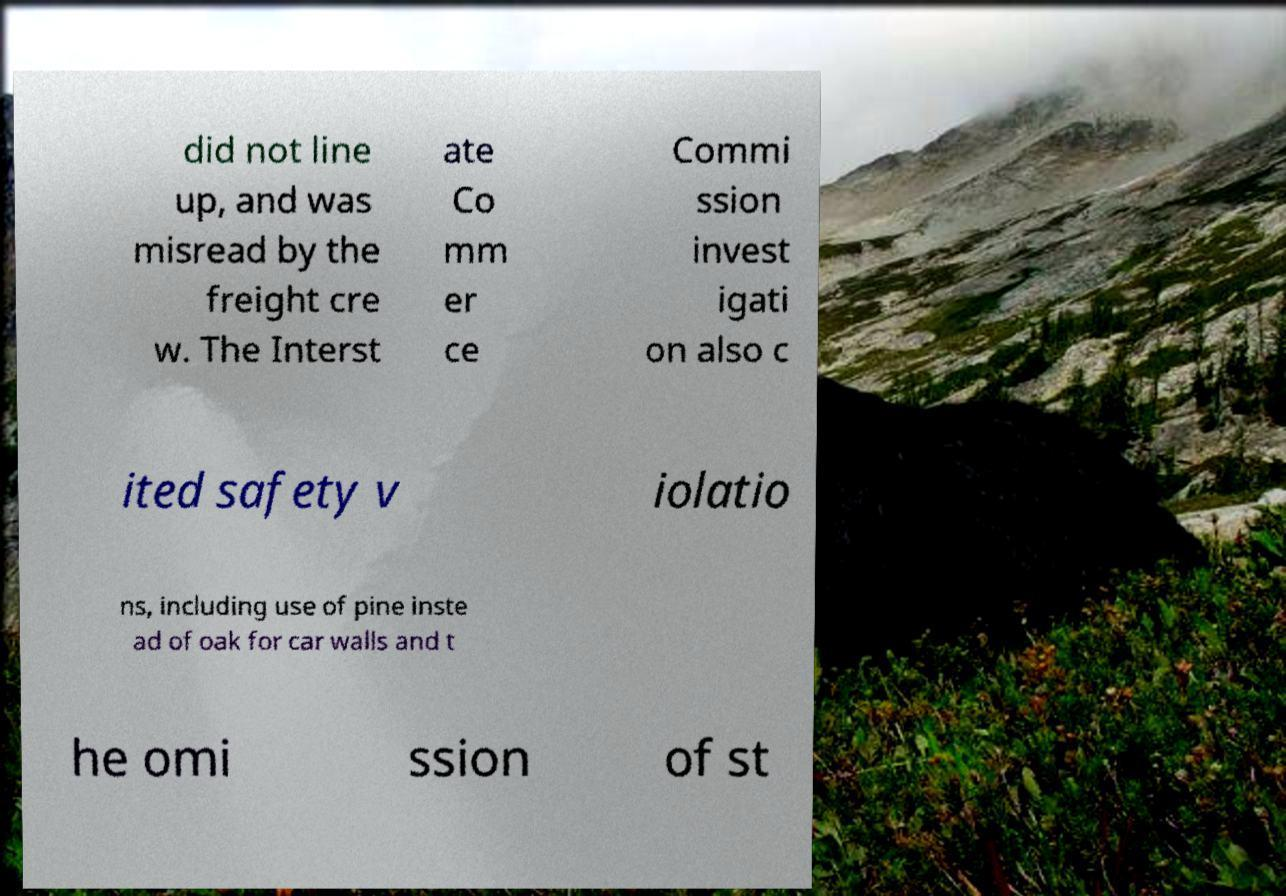Could you extract and type out the text from this image? did not line up, and was misread by the freight cre w. The Interst ate Co mm er ce Commi ssion invest igati on also c ited safety v iolatio ns, including use of pine inste ad of oak for car walls and t he omi ssion of st 